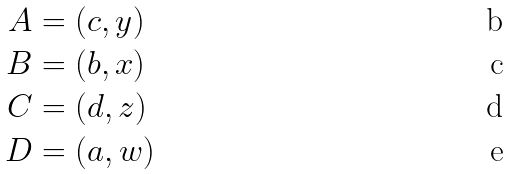Convert formula to latex. <formula><loc_0><loc_0><loc_500><loc_500>A & = ( c , y ) \\ B & = ( b , x ) \\ C & = ( d , z ) \\ D & = ( a , w )</formula> 